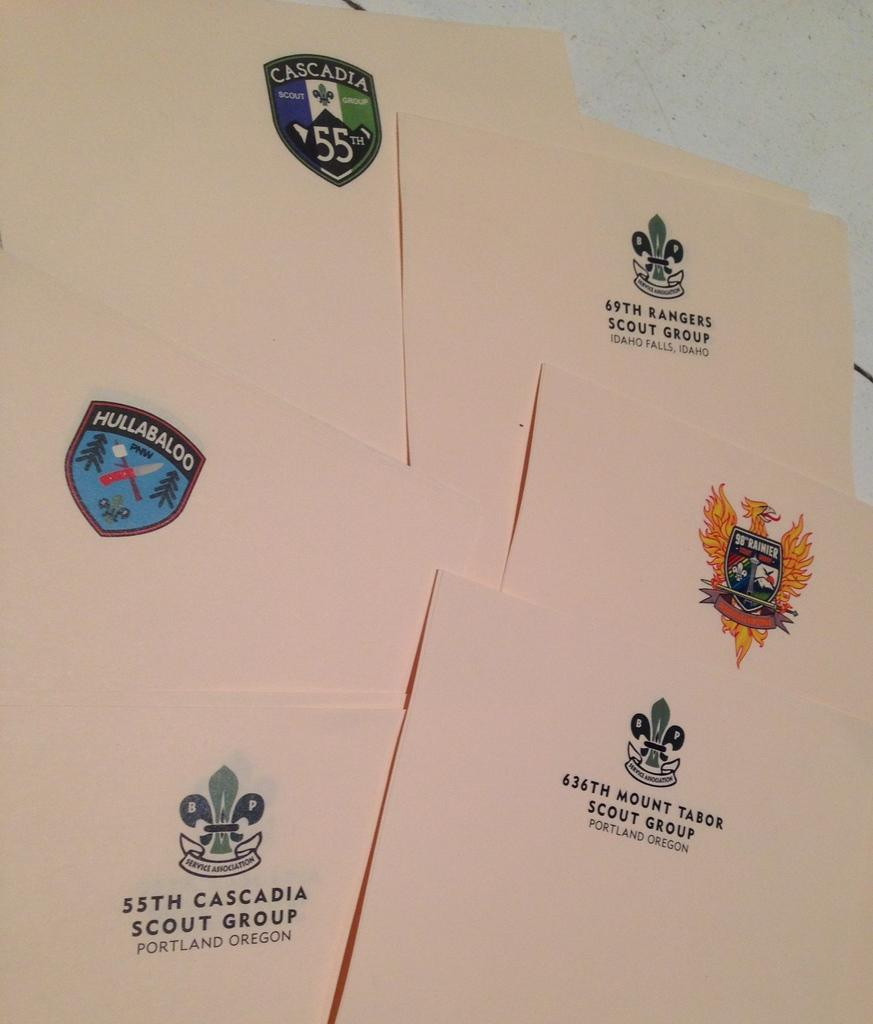<image>
Render a clear and concise summary of the photo. The 55th cascadia group in on the table 